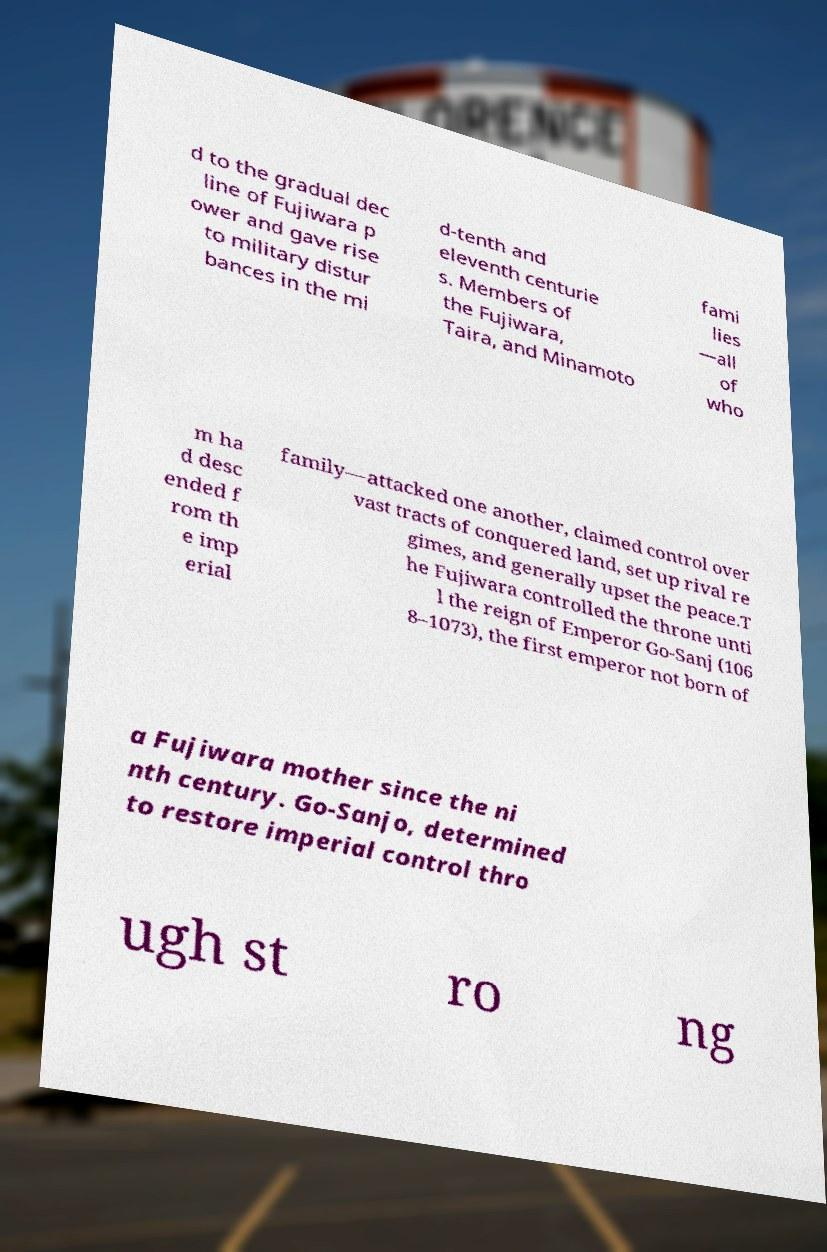Could you extract and type out the text from this image? d to the gradual dec line of Fujiwara p ower and gave rise to military distur bances in the mi d-tenth and eleventh centurie s. Members of the Fujiwara, Taira, and Minamoto fami lies —all of who m ha d desc ended f rom th e imp erial family—attacked one another, claimed control over vast tracts of conquered land, set up rival re gimes, and generally upset the peace.T he Fujiwara controlled the throne unti l the reign of Emperor Go-Sanj (106 8–1073), the first emperor not born of a Fujiwara mother since the ni nth century. Go-Sanjo, determined to restore imperial control thro ugh st ro ng 